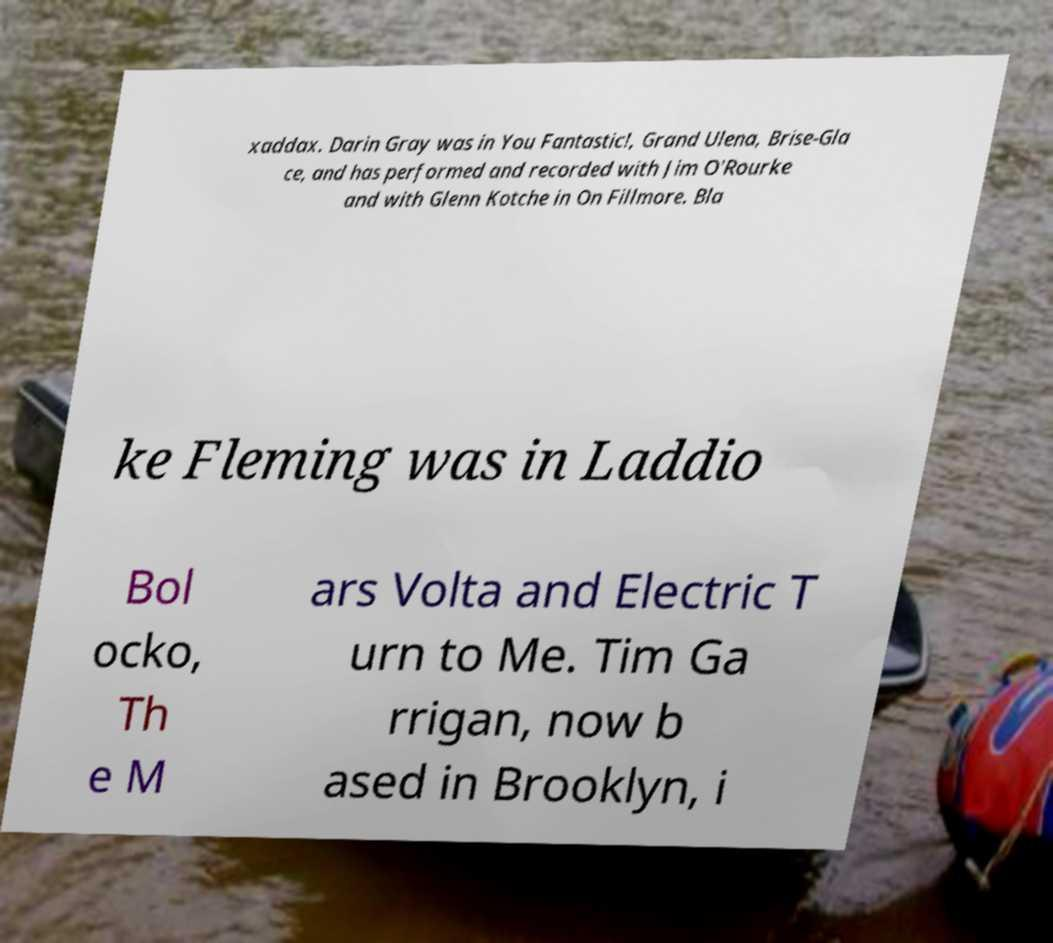For documentation purposes, I need the text within this image transcribed. Could you provide that? xaddax. Darin Gray was in You Fantastic!, Grand Ulena, Brise-Gla ce, and has performed and recorded with Jim O'Rourke and with Glenn Kotche in On Fillmore. Bla ke Fleming was in Laddio Bol ocko, Th e M ars Volta and Electric T urn to Me. Tim Ga rrigan, now b ased in Brooklyn, i 